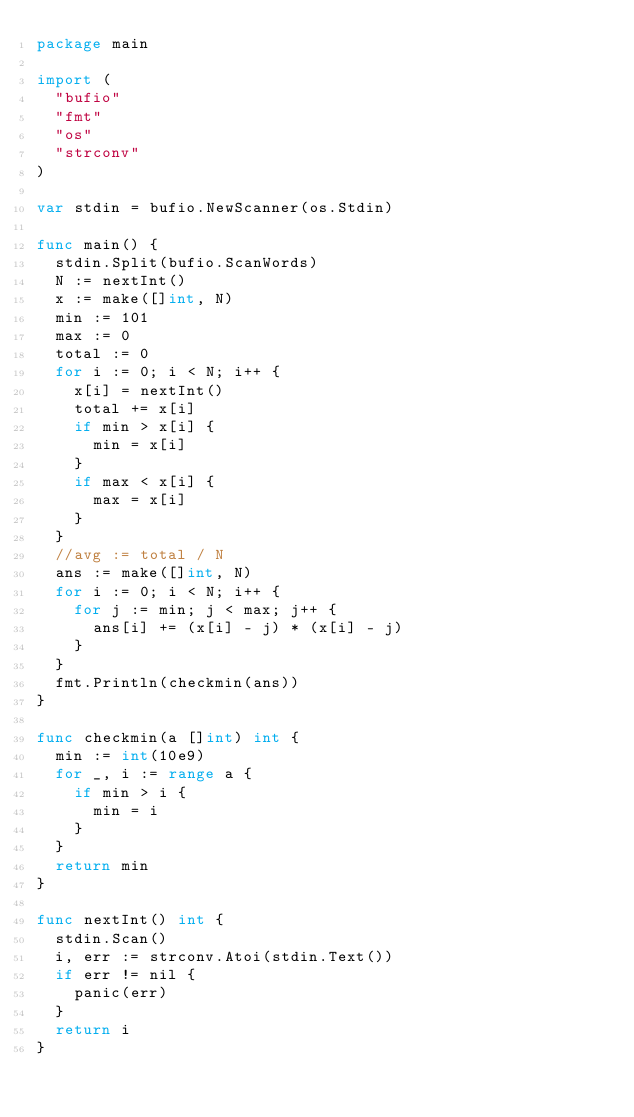Convert code to text. <code><loc_0><loc_0><loc_500><loc_500><_Go_>package main

import (
	"bufio"
	"fmt"
	"os"
	"strconv"
)

var stdin = bufio.NewScanner(os.Stdin)

func main() {
	stdin.Split(bufio.ScanWords)
	N := nextInt()
	x := make([]int, N)
	min := 101
	max := 0
	total := 0
	for i := 0; i < N; i++ {
		x[i] = nextInt()
		total += x[i]
		if min > x[i] {
			min = x[i]
		}
		if max < x[i] {
			max = x[i]
		}
	}
	//avg := total / N
	ans := make([]int, N)
	for i := 0; i < N; i++ {
		for j := min; j < max; j++ {
			ans[i] += (x[i] - j) * (x[i] - j)
		}
	}
	fmt.Println(checkmin(ans))
}

func checkmin(a []int) int {
	min := int(10e9)
	for _, i := range a {
		if min > i {
			min = i
		}
	}
	return min
}

func nextInt() int {
	stdin.Scan()
	i, err := strconv.Atoi(stdin.Text())
	if err != nil {
		panic(err)
	}
	return i
}
</code> 